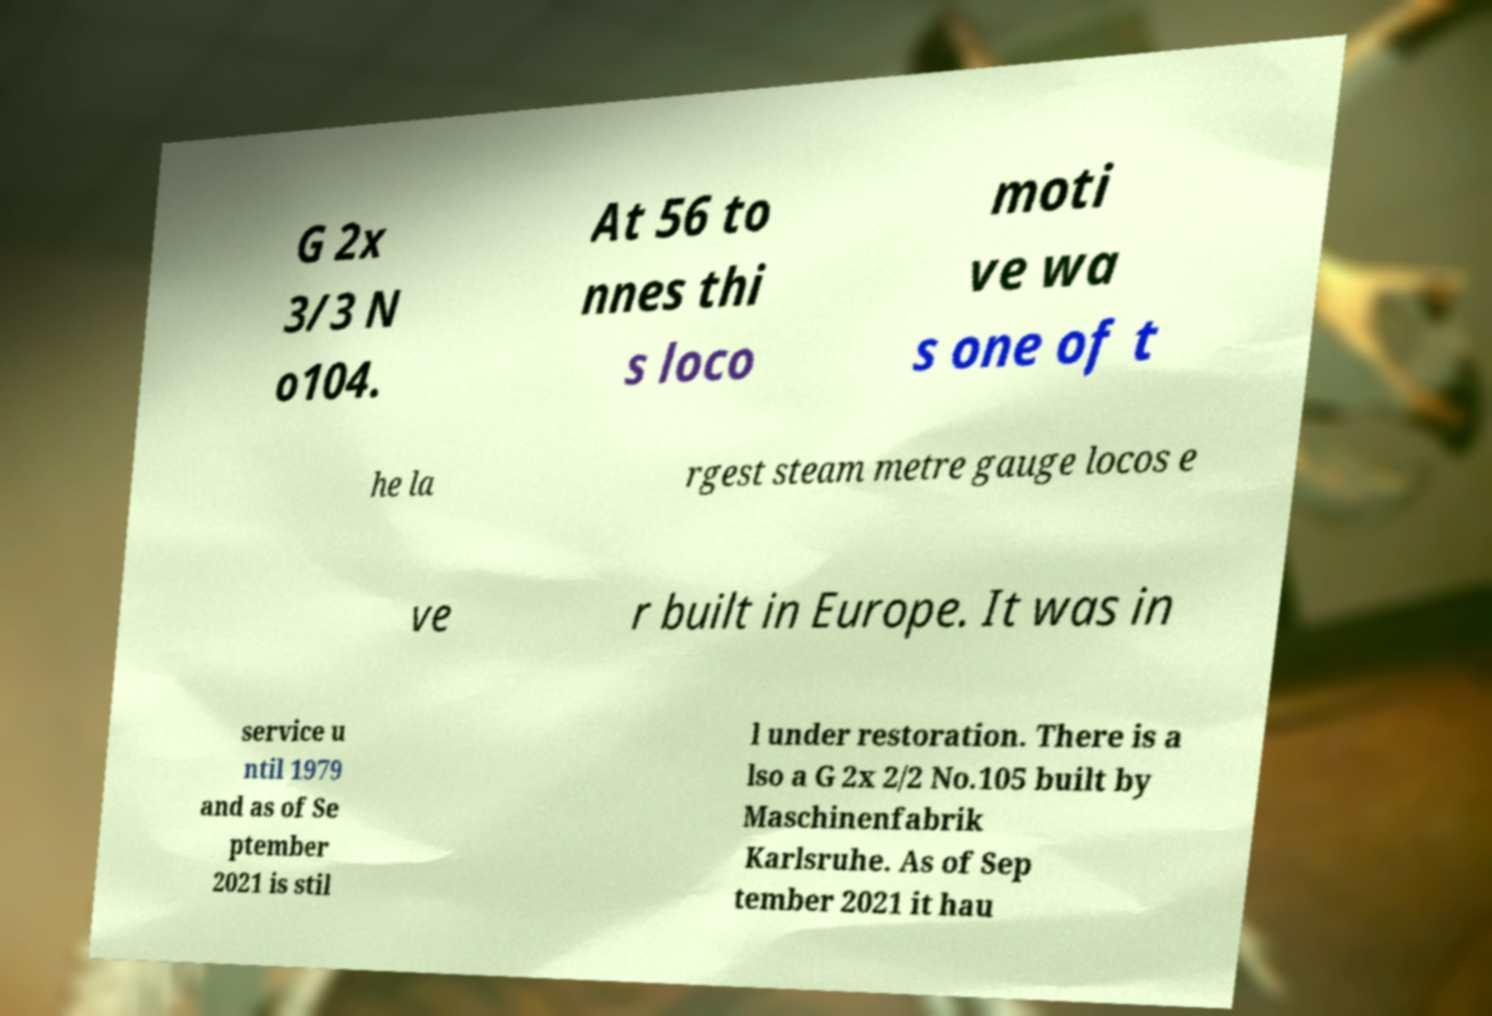Can you accurately transcribe the text from the provided image for me? G 2x 3/3 N o104. At 56 to nnes thi s loco moti ve wa s one of t he la rgest steam metre gauge locos e ve r built in Europe. It was in service u ntil 1979 and as of Se ptember 2021 is stil l under restoration. There is a lso a G 2x 2/2 No.105 built by Maschinenfabrik Karlsruhe. As of Sep tember 2021 it hau 